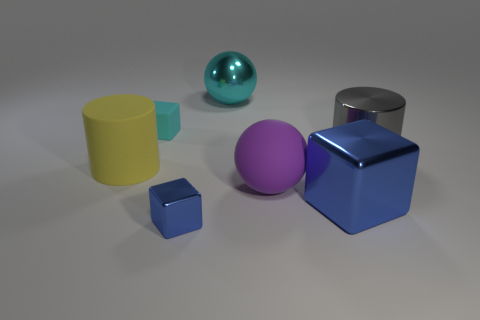Add 2 large matte balls. How many objects exist? 9 Subtract all tiny shiny blocks. How many blocks are left? 2 Subtract all cyan cubes. How many cubes are left? 2 Add 5 blue metallic objects. How many blue metallic objects are left? 7 Add 3 large shiny objects. How many large shiny objects exist? 6 Subtract 0 brown balls. How many objects are left? 7 Subtract all blocks. How many objects are left? 4 Subtract 1 cubes. How many cubes are left? 2 Subtract all blue balls. Subtract all blue cylinders. How many balls are left? 2 Subtract all yellow balls. How many cyan cubes are left? 1 